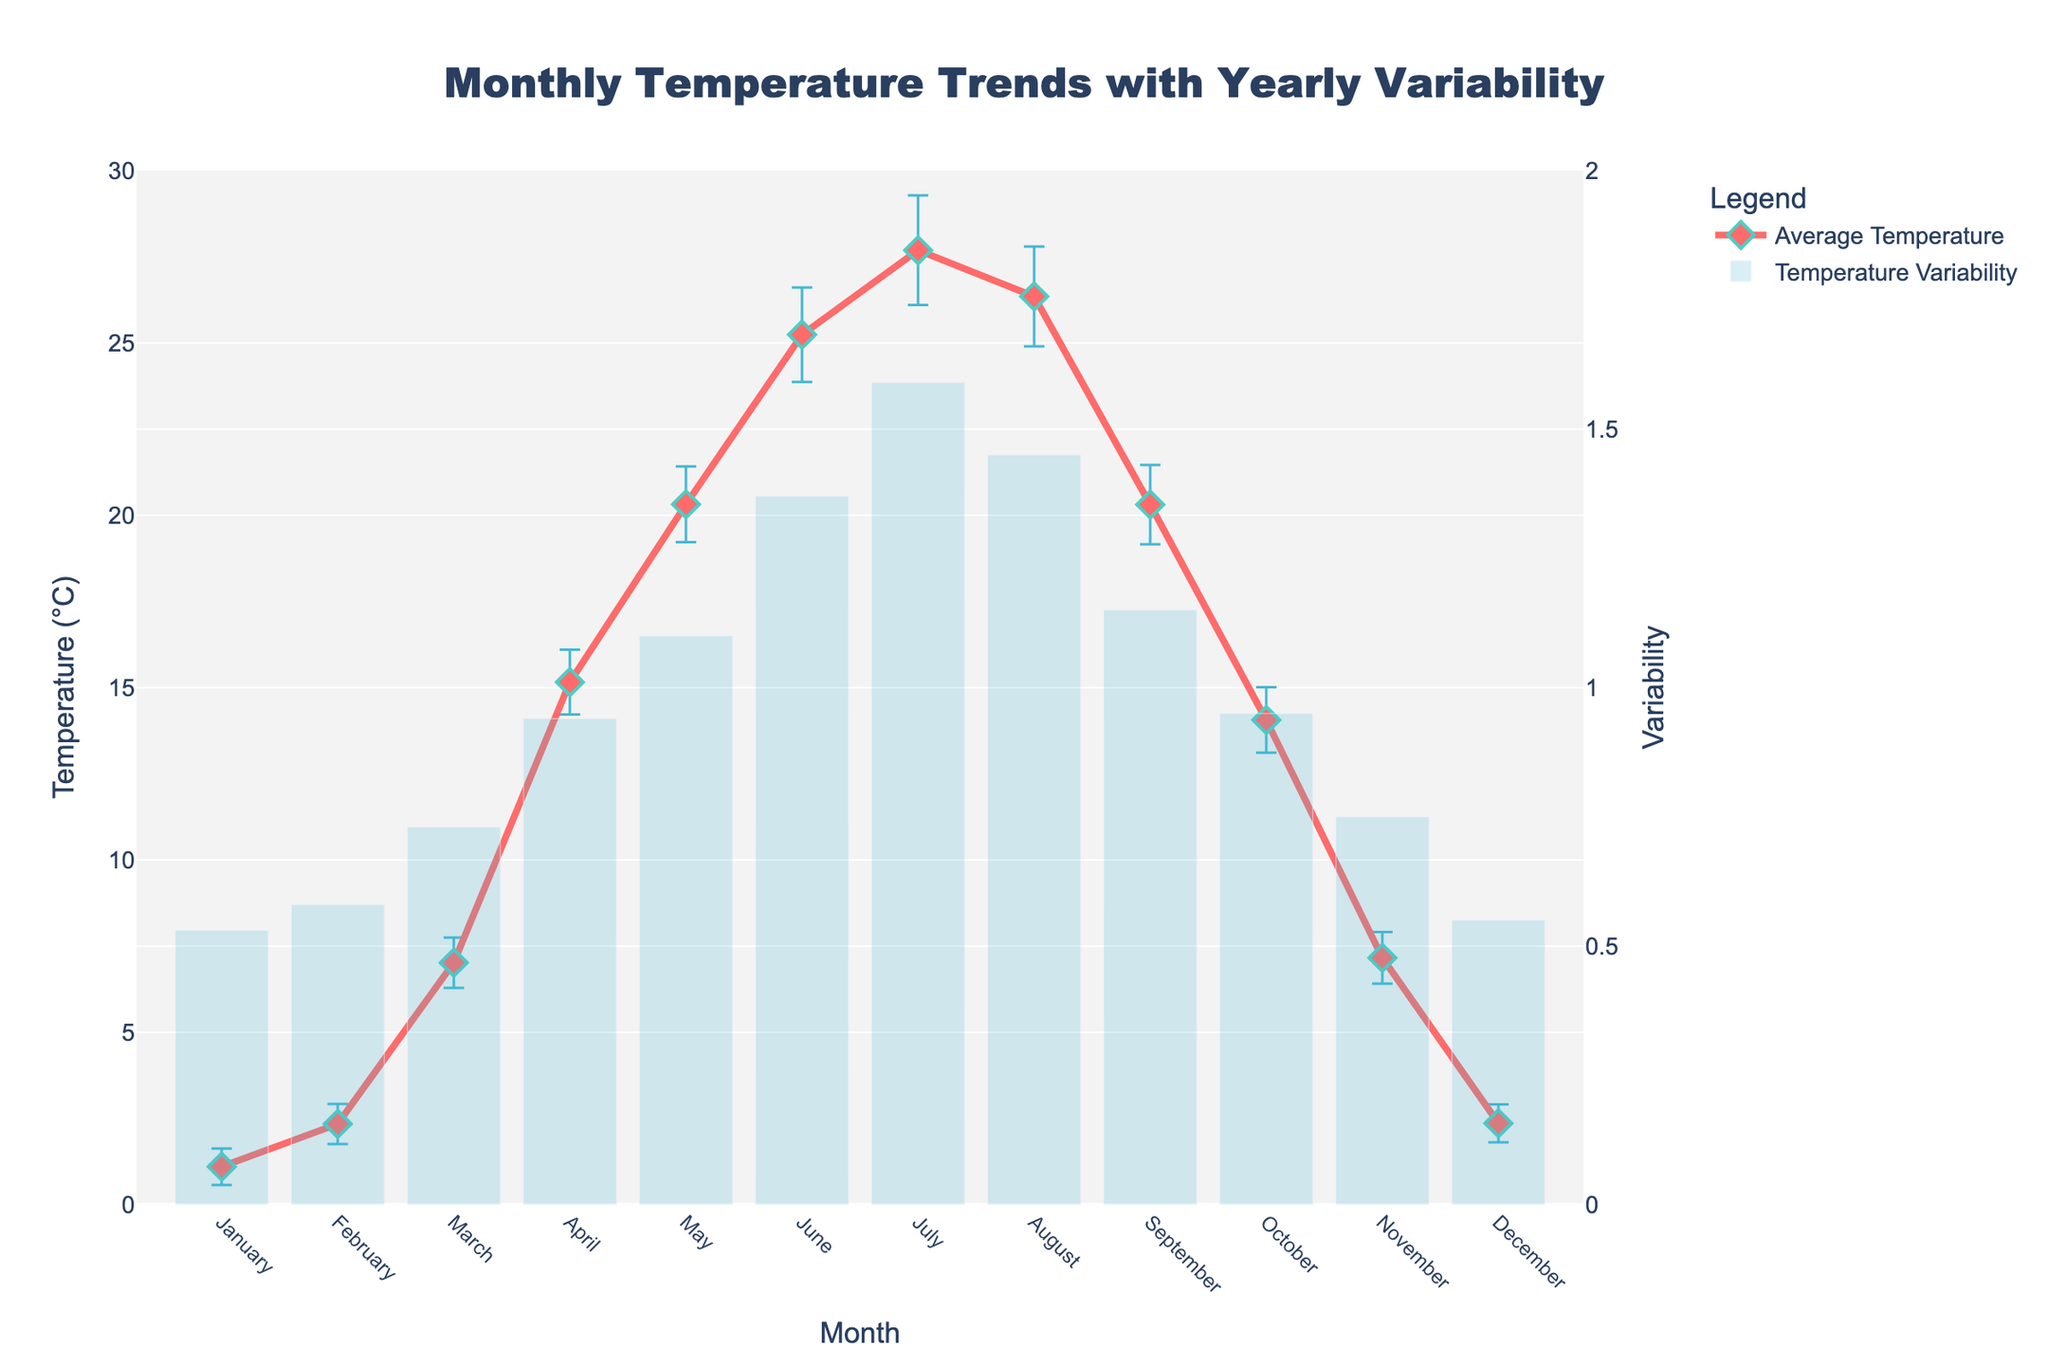What is the title of the plot? The title is displayed at the top center of the plot. It reads "Monthly Temperature Trends with Yearly Variability."
Answer: Monthly Temperature Trends with Yearly Variability What are the labels on the X and Y axes? The X axis is labeled "Month," and the Y axis is labeled "Temperature (°C)" while the secondary Y axis is labeled "Variability." These labels help identify what is being measured along each axis.
Answer: Month, Temperature (°C), Variability Which month has the highest average temperature? Looking at the line plot for "Average Temperature," it peaks in July. This indicates that July has the highest average temperature.
Answer: July What is the average variability across all months? To find the average variability, sum the "Temperature Variability" values for each month and divide by 12 (the number of months). (0.5 + 0.6 + 0.7 + 0.9 + 1.1 + 1.4 + 1.6 + 1.5 + 1.2 + 1.0 + 0.8 + 0.6) / 12 = 1.0
Answer: 1.0 What is the trend of average temperature from January to December? Observing the line plot, the average temperature increases from January, peaks in July, and then decreases towards December, forming a U-shaped pattern.
Answer: U-shaped pattern What is the difference between the highest and lowest average temperatures recorded for any month? The highest average temperature is in July (27.8°C), and the lowest is in January (1.0°C). The difference is 27.8 - 1.0 = 26.8°C.
Answer: 26.8°C How does the temperature variability compare between summer months (June, July, August) and winter months (December, January, February)? Observing the bar plot for "Temperature Variability," it's evident that summer months (June, July, August) have higher variability (1.3 to 1.6) compared to winter months (December, January, February) which range from 0.5 to 0.7.
Answer: Higher in summer, lower in winter Which month has the lowest variability, and what is its value? Examining the bar plot, November has the lowest variability value, which is 0.7.
Answer: November, 0.7 